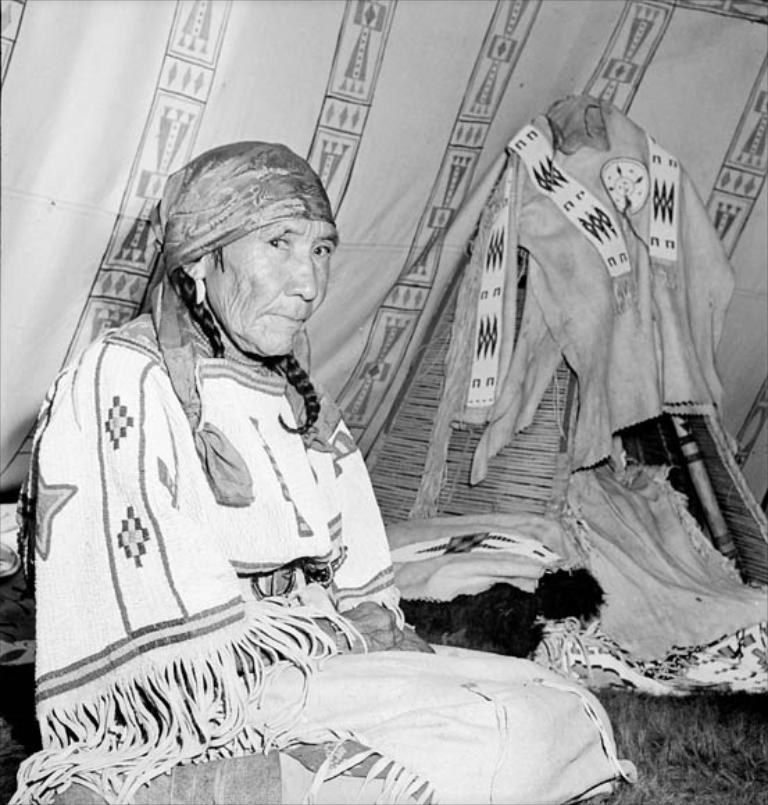Who is present in the image? There is a woman in the image. What is the woman sitting on? The woman is sitting on a grass surface. What type of material is visible in the image? There is cloth visible in the image. What else can be seen in the image besides the woman and the cloth? There are objects in the image. What type of shelter is present in the image? There is a tent in the image. What language is the woman speaking in the image? The image does not provide any information about the language being spoken, as there is no audio or text present. 